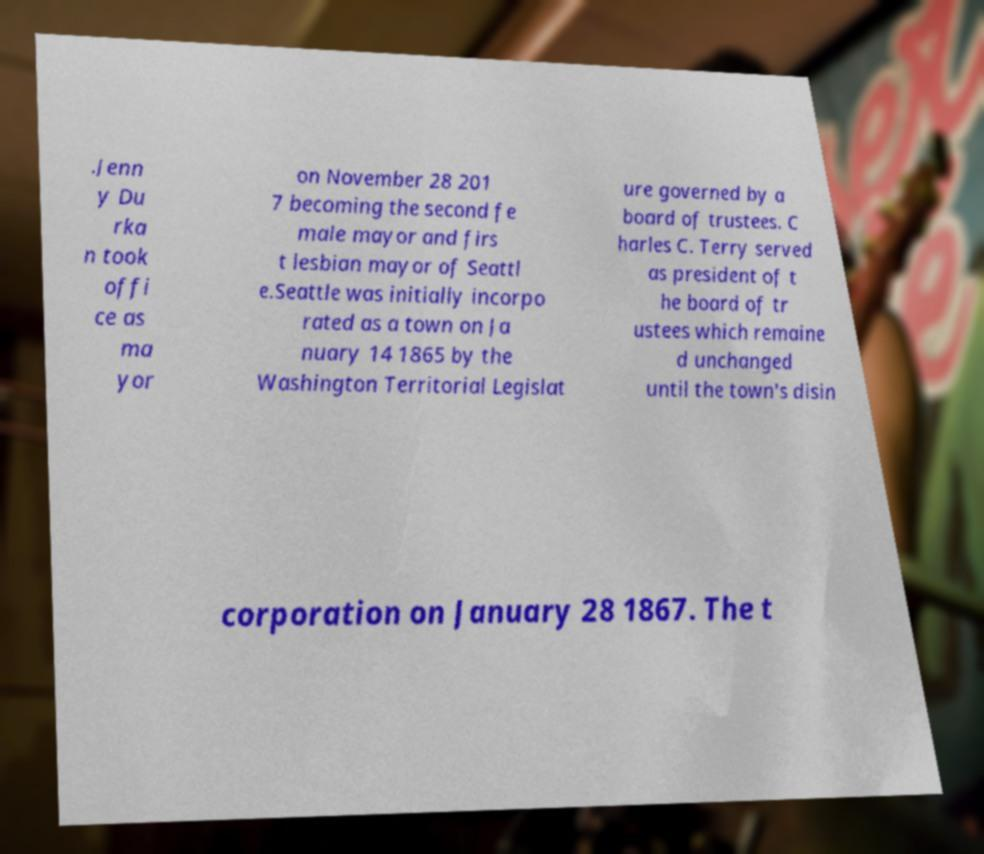Can you accurately transcribe the text from the provided image for me? .Jenn y Du rka n took offi ce as ma yor on November 28 201 7 becoming the second fe male mayor and firs t lesbian mayor of Seattl e.Seattle was initially incorpo rated as a town on Ja nuary 14 1865 by the Washington Territorial Legislat ure governed by a board of trustees. C harles C. Terry served as president of t he board of tr ustees which remaine d unchanged until the town's disin corporation on January 28 1867. The t 